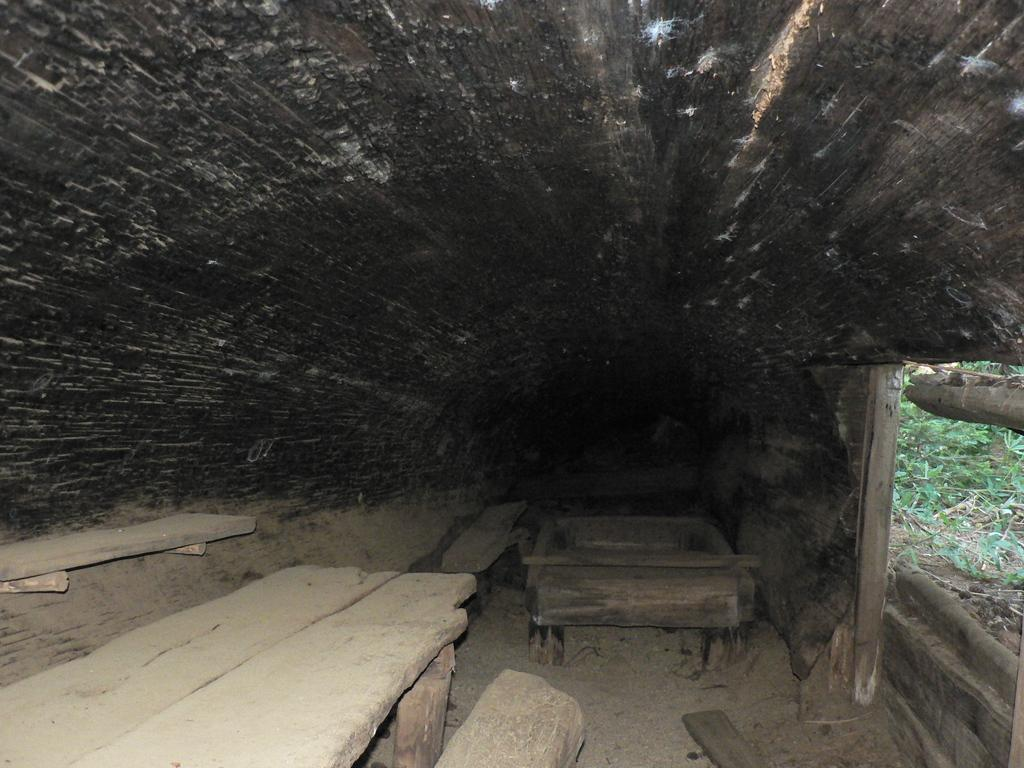What material are the benches made of in the image? The benches in the image are made of wood. What type of vegetation can be seen in the image? There are plants visible in the image. What other wooden elements can be seen in the image? There are wooden planks in the image. How many cows are grazing near the wooden benches in the image? There are no cows present in the image. Is there an attack happening near the wooden benches in the image? There is no indication of an attack in the image. 